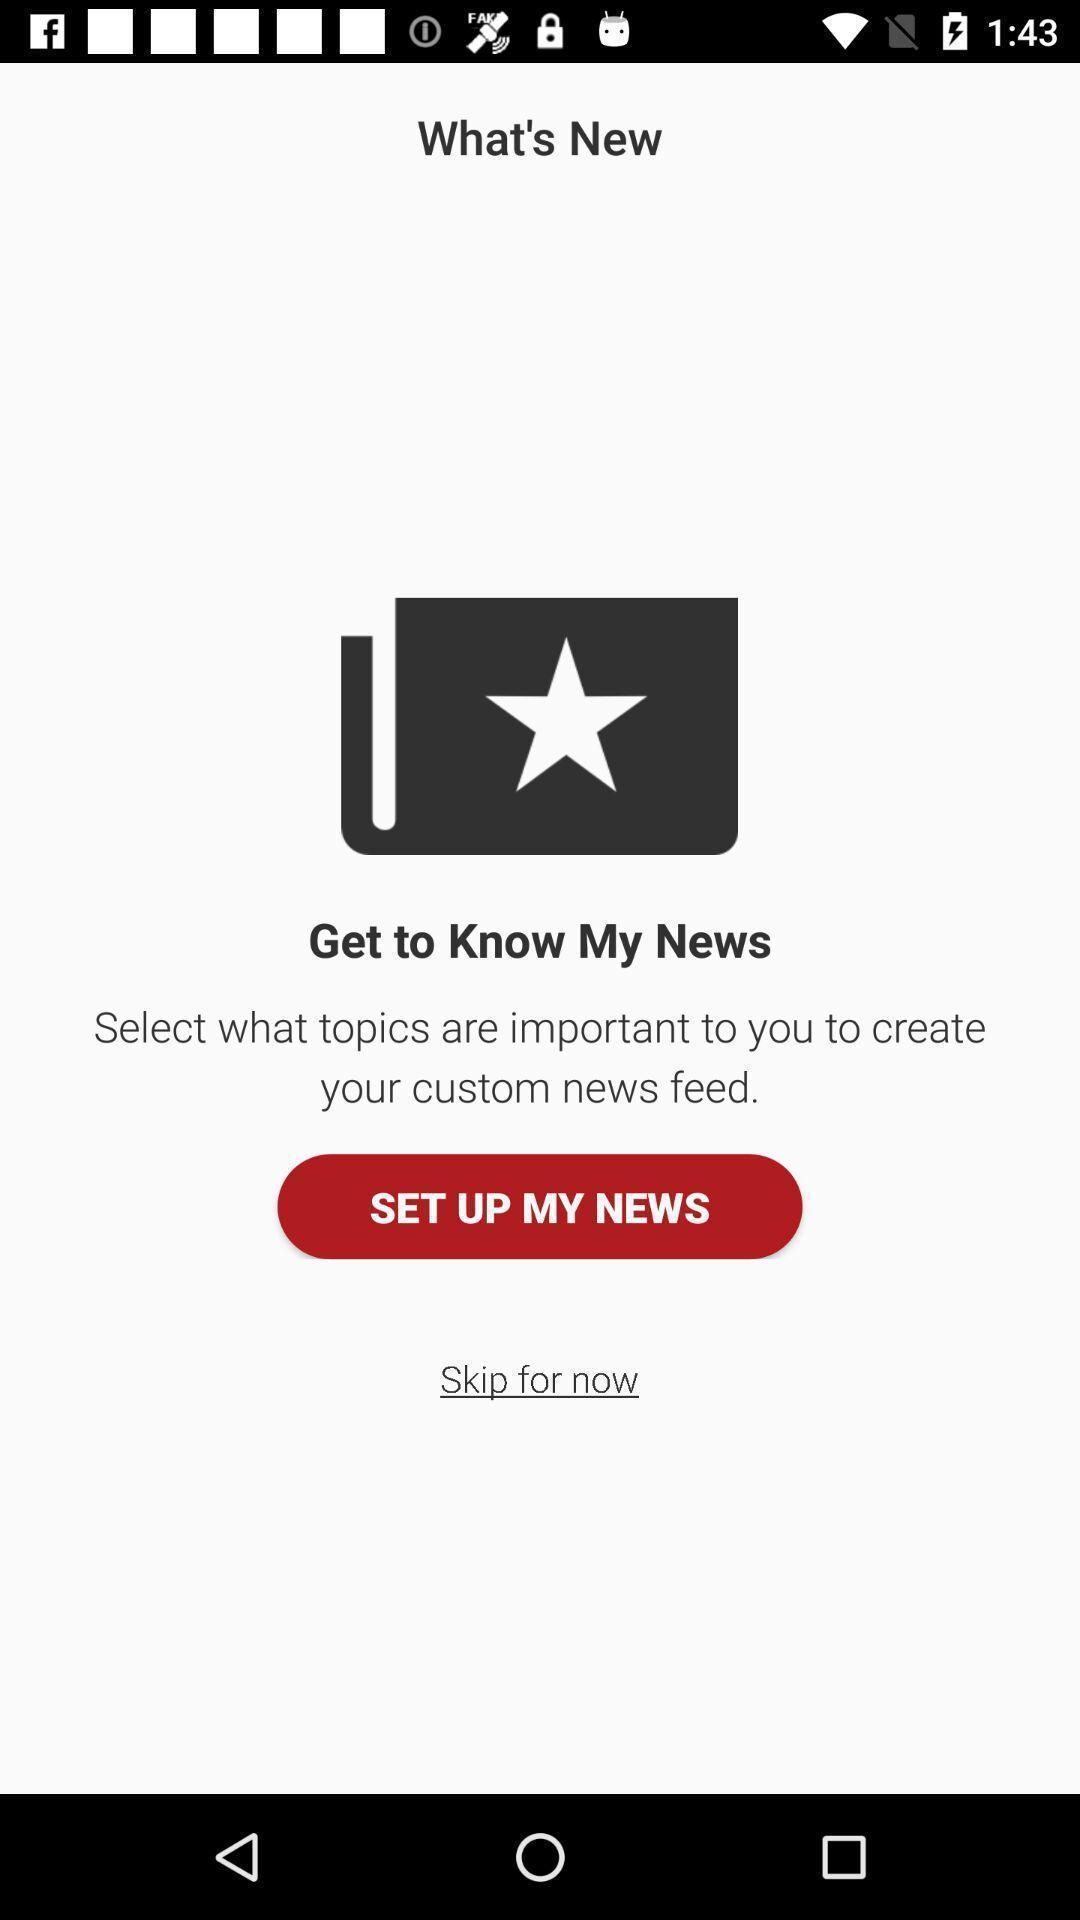Provide a description of this screenshot. Starting page for the news channel to see news. 